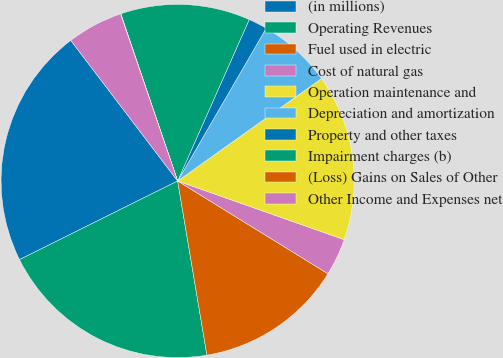Convert chart to OTSL. <chart><loc_0><loc_0><loc_500><loc_500><pie_chart><fcel>(in millions)<fcel>Operating Revenues<fcel>Fuel used in electric<fcel>Cost of natural gas<fcel>Operation maintenance and<fcel>Depreciation and amortization<fcel>Property and other taxes<fcel>Impairment charges (b)<fcel>(Loss) Gains on Sales of Other<fcel>Other Income and Expenses net<nl><fcel>22.0%<fcel>20.31%<fcel>13.55%<fcel>3.41%<fcel>15.24%<fcel>6.79%<fcel>1.72%<fcel>11.86%<fcel>0.03%<fcel>5.1%<nl></chart> 